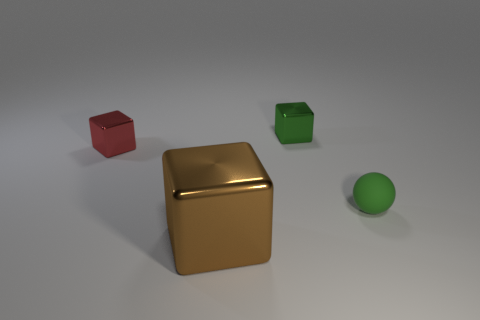Subtract all tiny green blocks. How many blocks are left? 2 Add 3 cyan metal cylinders. How many objects exist? 7 Subtract 1 blocks. How many blocks are left? 2 Subtract all red blocks. How many blocks are left? 2 Subtract all cubes. How many objects are left? 1 Subtract all blue spheres. How many red cubes are left? 1 Add 1 big brown objects. How many big brown objects are left? 2 Add 1 tiny shiny blocks. How many tiny shiny blocks exist? 3 Subtract 0 blue spheres. How many objects are left? 4 Subtract all blue blocks. Subtract all blue spheres. How many blocks are left? 3 